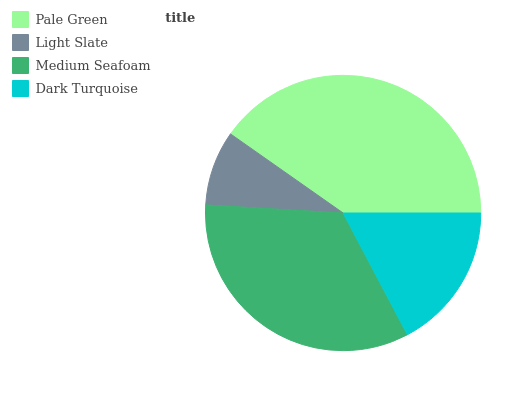Is Light Slate the minimum?
Answer yes or no. Yes. Is Pale Green the maximum?
Answer yes or no. Yes. Is Medium Seafoam the minimum?
Answer yes or no. No. Is Medium Seafoam the maximum?
Answer yes or no. No. Is Medium Seafoam greater than Light Slate?
Answer yes or no. Yes. Is Light Slate less than Medium Seafoam?
Answer yes or no. Yes. Is Light Slate greater than Medium Seafoam?
Answer yes or no. No. Is Medium Seafoam less than Light Slate?
Answer yes or no. No. Is Medium Seafoam the high median?
Answer yes or no. Yes. Is Dark Turquoise the low median?
Answer yes or no. Yes. Is Dark Turquoise the high median?
Answer yes or no. No. Is Medium Seafoam the low median?
Answer yes or no. No. 